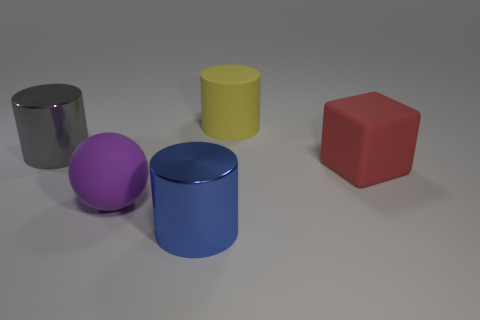Add 4 tiny cyan balls. How many objects exist? 9 Subtract all cylinders. How many objects are left? 2 Subtract 0 red cylinders. How many objects are left? 5 Subtract all small purple metallic blocks. Subtract all large purple things. How many objects are left? 4 Add 4 large yellow rubber cylinders. How many large yellow rubber cylinders are left? 5 Add 3 large purple matte spheres. How many large purple matte spheres exist? 4 